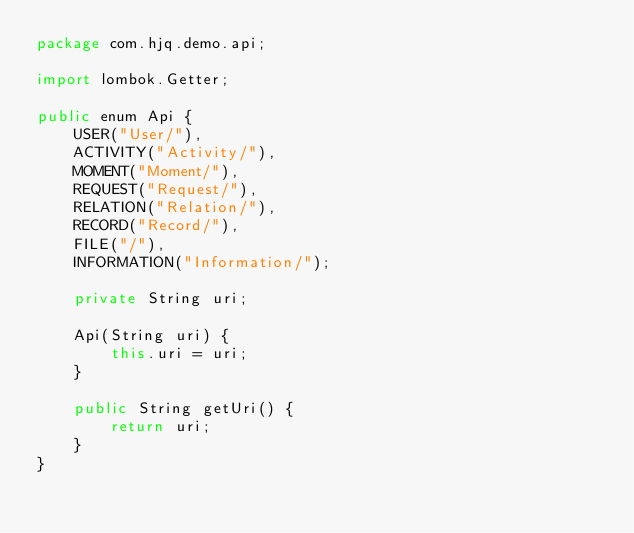<code> <loc_0><loc_0><loc_500><loc_500><_Java_>package com.hjq.demo.api;

import lombok.Getter;

public enum Api {
    USER("User/"),
    ACTIVITY("Activity/"),
    MOMENT("Moment/"),
    REQUEST("Request/"),
    RELATION("Relation/"),
    RECORD("Record/"),
    FILE("/"),
    INFORMATION("Information/");

    private String uri;

    Api(String uri) {
        this.uri = uri;
    }

    public String getUri() {
        return uri;
    }
}
</code> 